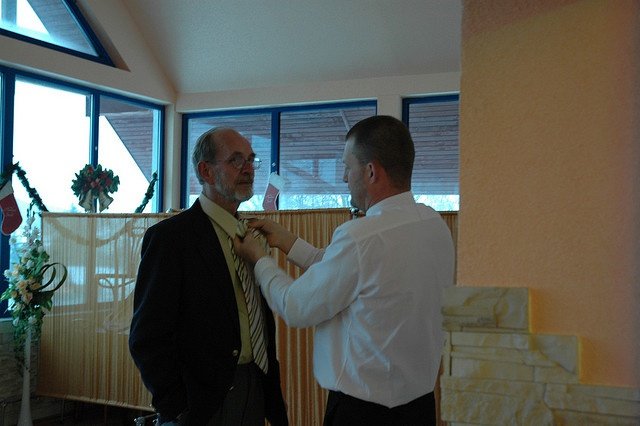Describe the objects in this image and their specific colors. I can see people in white, gray, and black tones, people in white, black, maroon, darkgreen, and gray tones, tie in white, black, darkgreen, and gray tones, and vase in white, black, and teal tones in this image. 